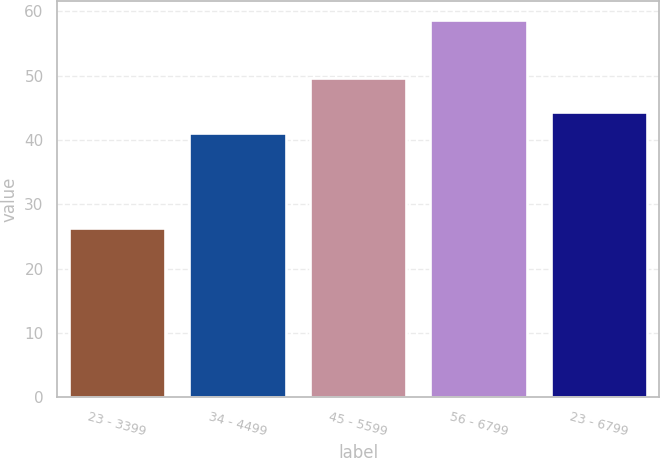<chart> <loc_0><loc_0><loc_500><loc_500><bar_chart><fcel>23 - 3399<fcel>34 - 4499<fcel>45 - 5599<fcel>56 - 6799<fcel>23 - 6799<nl><fcel>26.28<fcel>41.09<fcel>49.61<fcel>58.64<fcel>44.33<nl></chart> 